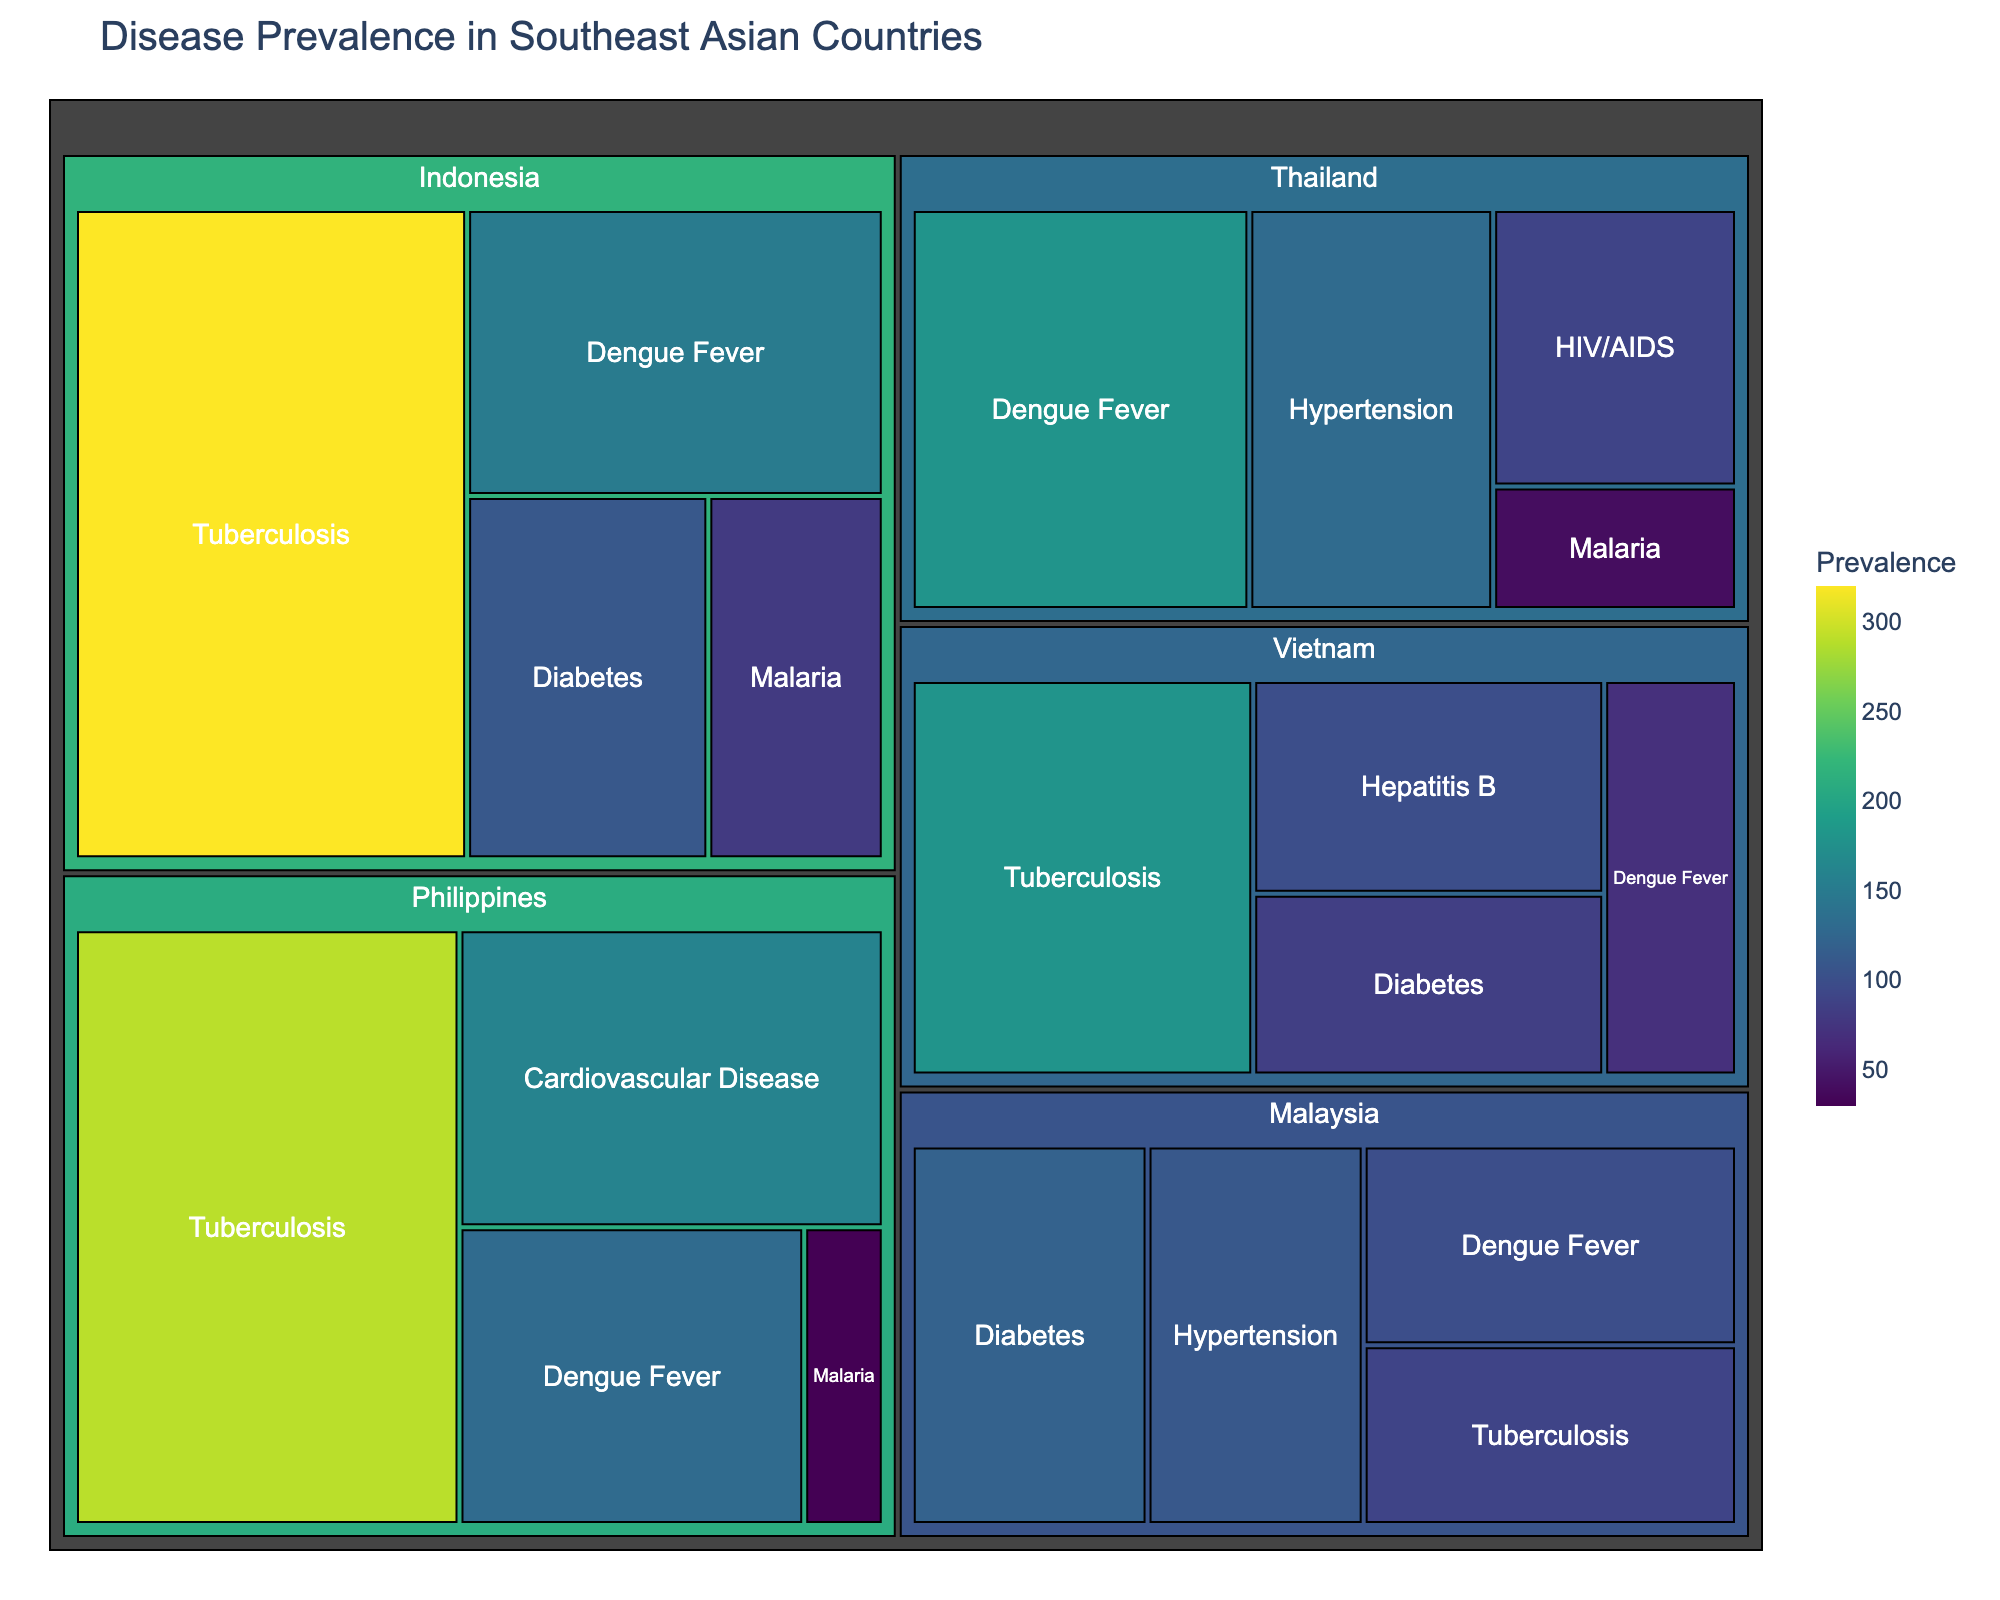What's the most prevalent disease in Indonesia? To determine the most prevalent disease in Indonesia, we look at the relative size of each tile within the Indonesia section. Tuberculosis has the largest tile, indicating its prevalence.
Answer: Tuberculosis Which country has the highest prevalence of Dengue Fever? By comparing the sizes of the tiles for Dengue Fever in each country, Thailand has the largest tile, indicating it has the highest prevalence.
Answer: Thailand Compare the total prevalence of Tuberculosis in the Philippines and Vietnam. Which country has a higher prevalence? Reviewing the sizes of the Tuberculosis tiles in both countries reveals that the Philippines (290) has a higher prevalence than Vietnam (180).
Answer: Philippines What's the total prevalence of non-communicable diseases in Malaysia? Non-communicable diseases listed for Malaysia are Diabetes and Hypertension. The total prevalence is the sum of their values: 120 for Diabetes and 110 for Hypertension, which totals to 230.
Answer: 230 Which disease has the lowest prevalence in Southeast Asia according to the treemap? The smallest tile on the treemap indicates the lowest prevalence. Malaria in the Philippines has the smallest tile with a value of 30.
Answer: Malaria in the Philippines In which country is Hypertension a prevalent disease? From the treemap, Hypertension appears in Thailand and Malaysia.
Answer: Thailand, Malaysia Compare the prevalence of Dengue Fever in Indonesia and Vietnam. Which country has a higher prevalence? Comparing the sizes of the Dengue Fever tiles, Indonesia has a prevalence of 150, while Vietnam has 70. Thus, Indonesia has a higher prevalence.
Answer: Indonesia How does the prevalence of Diabetes in Malaysia compare to Indonesia? Looking at the tiles for Diabetes in both countries, Malaysia has a prevalence of 120 and Indonesia has 110. Therefore, Malaysia's prevalence is higher.
Answer: Malaysia What’s the sum of the prevalence of Tuberculosis across all the countries? Sum up the values of Tuberculosis from each country: Indonesia (320), Vietnam (180), Philippines (290), and Malaysia (90). This gives a total of 880.
Answer: 880 